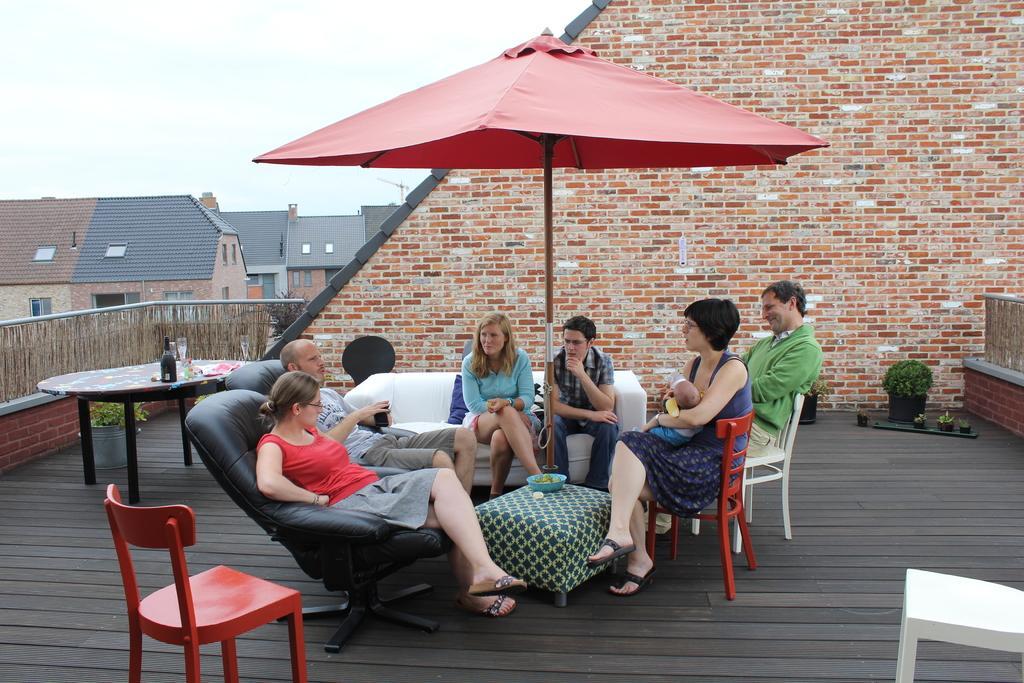In one or two sentences, can you explain what this image depicts? Completely an outdoor picture. This is an red umbrella. This persons are sitting on a couch and chairs. On this table there is a bowl. On this table there is a bottle and glass. This is a red chair. Far there are buildings with rooftop and windows. These are plants. 